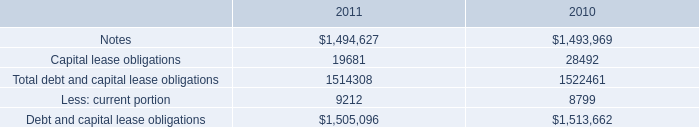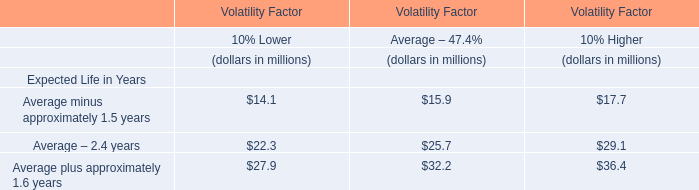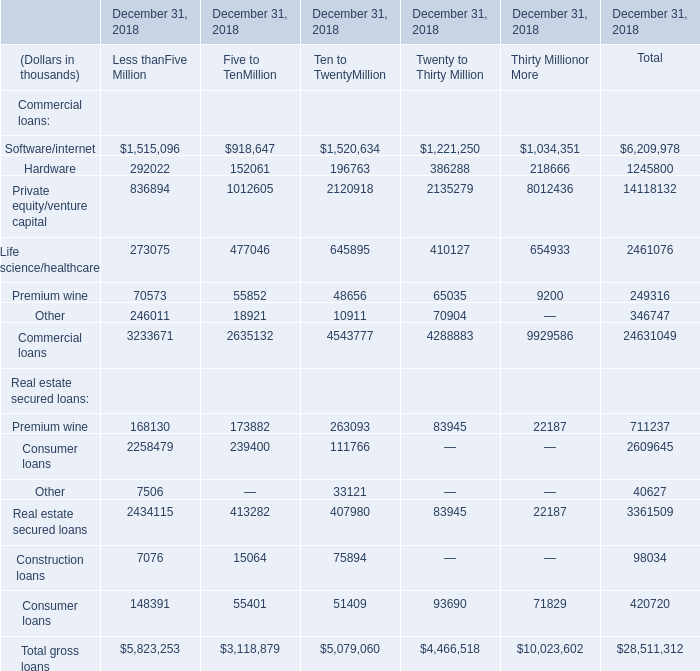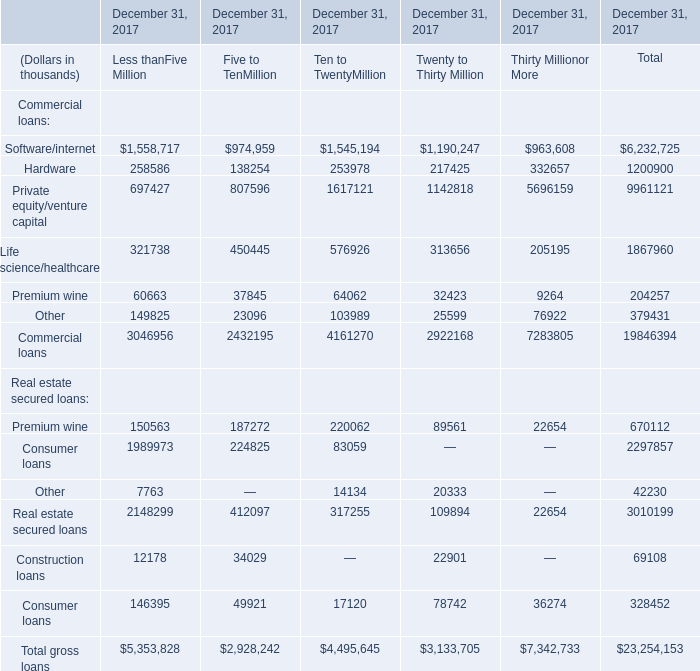What is the sum of Hardware of December 31, 2018 Less thanFive Million, Life science/healthcare of December 31, 2017 Ten to TwentyMillion, and Hardware of December 31, 2018 Total ? 
Computations: ((292022.0 + 576926.0) + 1245800.0)
Answer: 2114748.0. 